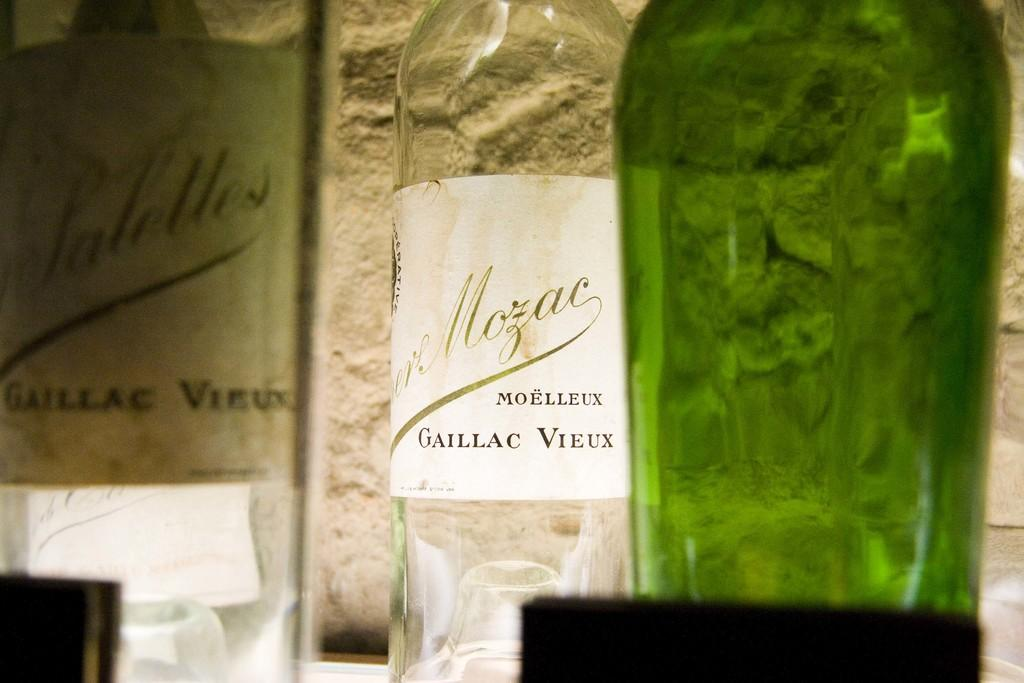<image>
Create a compact narrative representing the image presented. A bottle of Moelleux Gaillac Vieux shines in the light. 